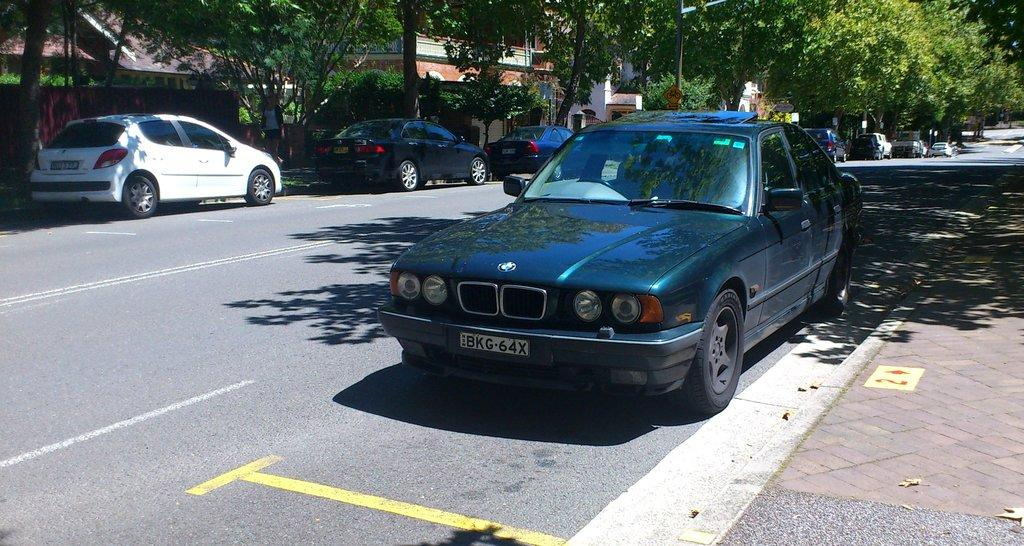What is the main feature of the image? There is a road in the image. What can be seen on the road? Vehicles are parked on the road. What type of natural elements are visible in the image? There are trees visible in the image. What type of man-made structure is present in the image? There is a building in the image. What type of cup is being used for treatment in the image? There is no cup or treatment present in the image. 